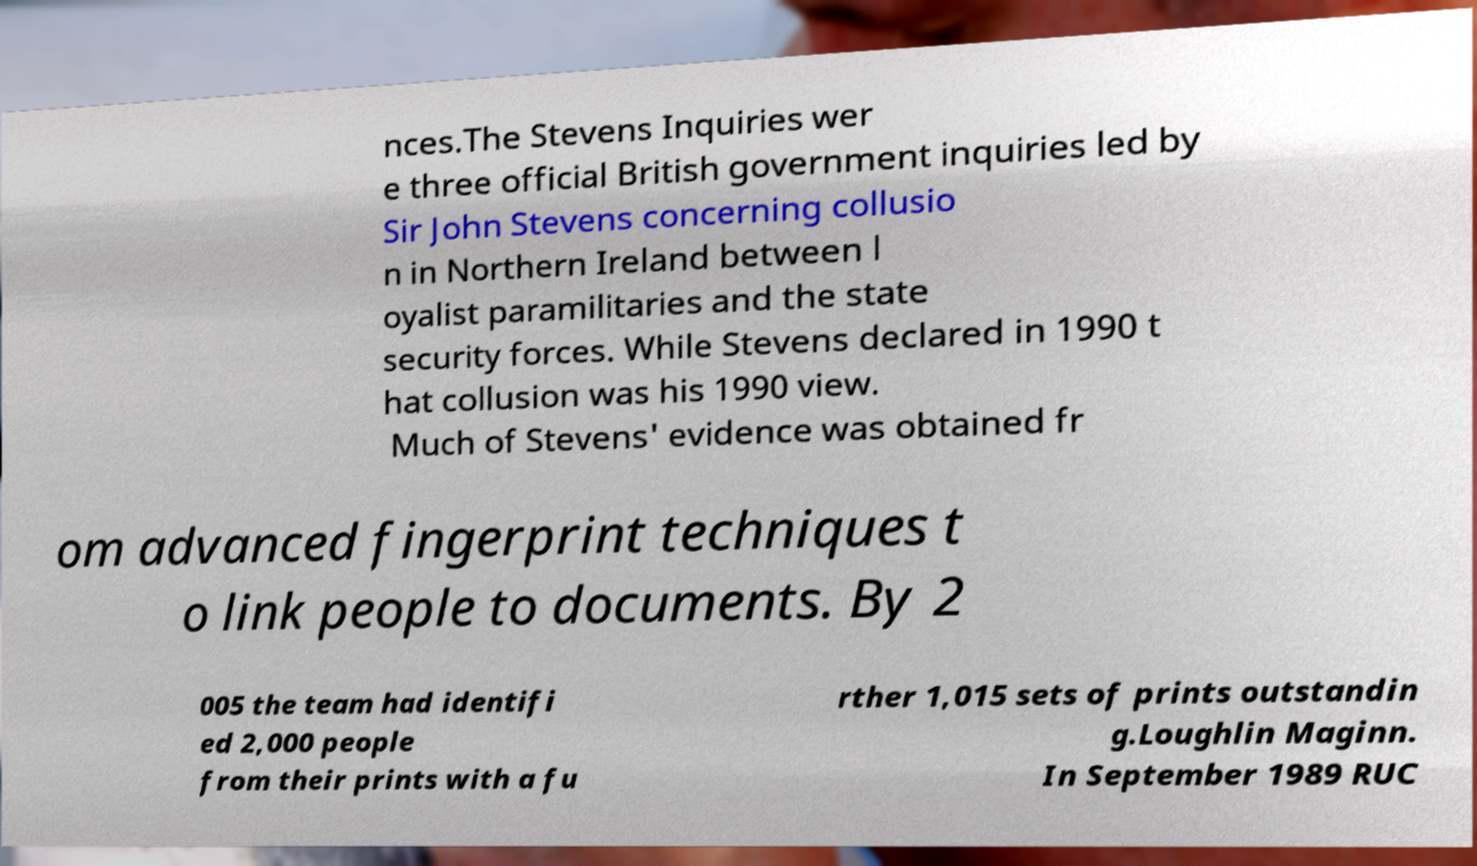What messages or text are displayed in this image? I need them in a readable, typed format. nces.The Stevens Inquiries wer e three official British government inquiries led by Sir John Stevens concerning collusio n in Northern Ireland between l oyalist paramilitaries and the state security forces. While Stevens declared in 1990 t hat collusion was his 1990 view. Much of Stevens' evidence was obtained fr om advanced fingerprint techniques t o link people to documents. By 2 005 the team had identifi ed 2,000 people from their prints with a fu rther 1,015 sets of prints outstandin g.Loughlin Maginn. In September 1989 RUC 